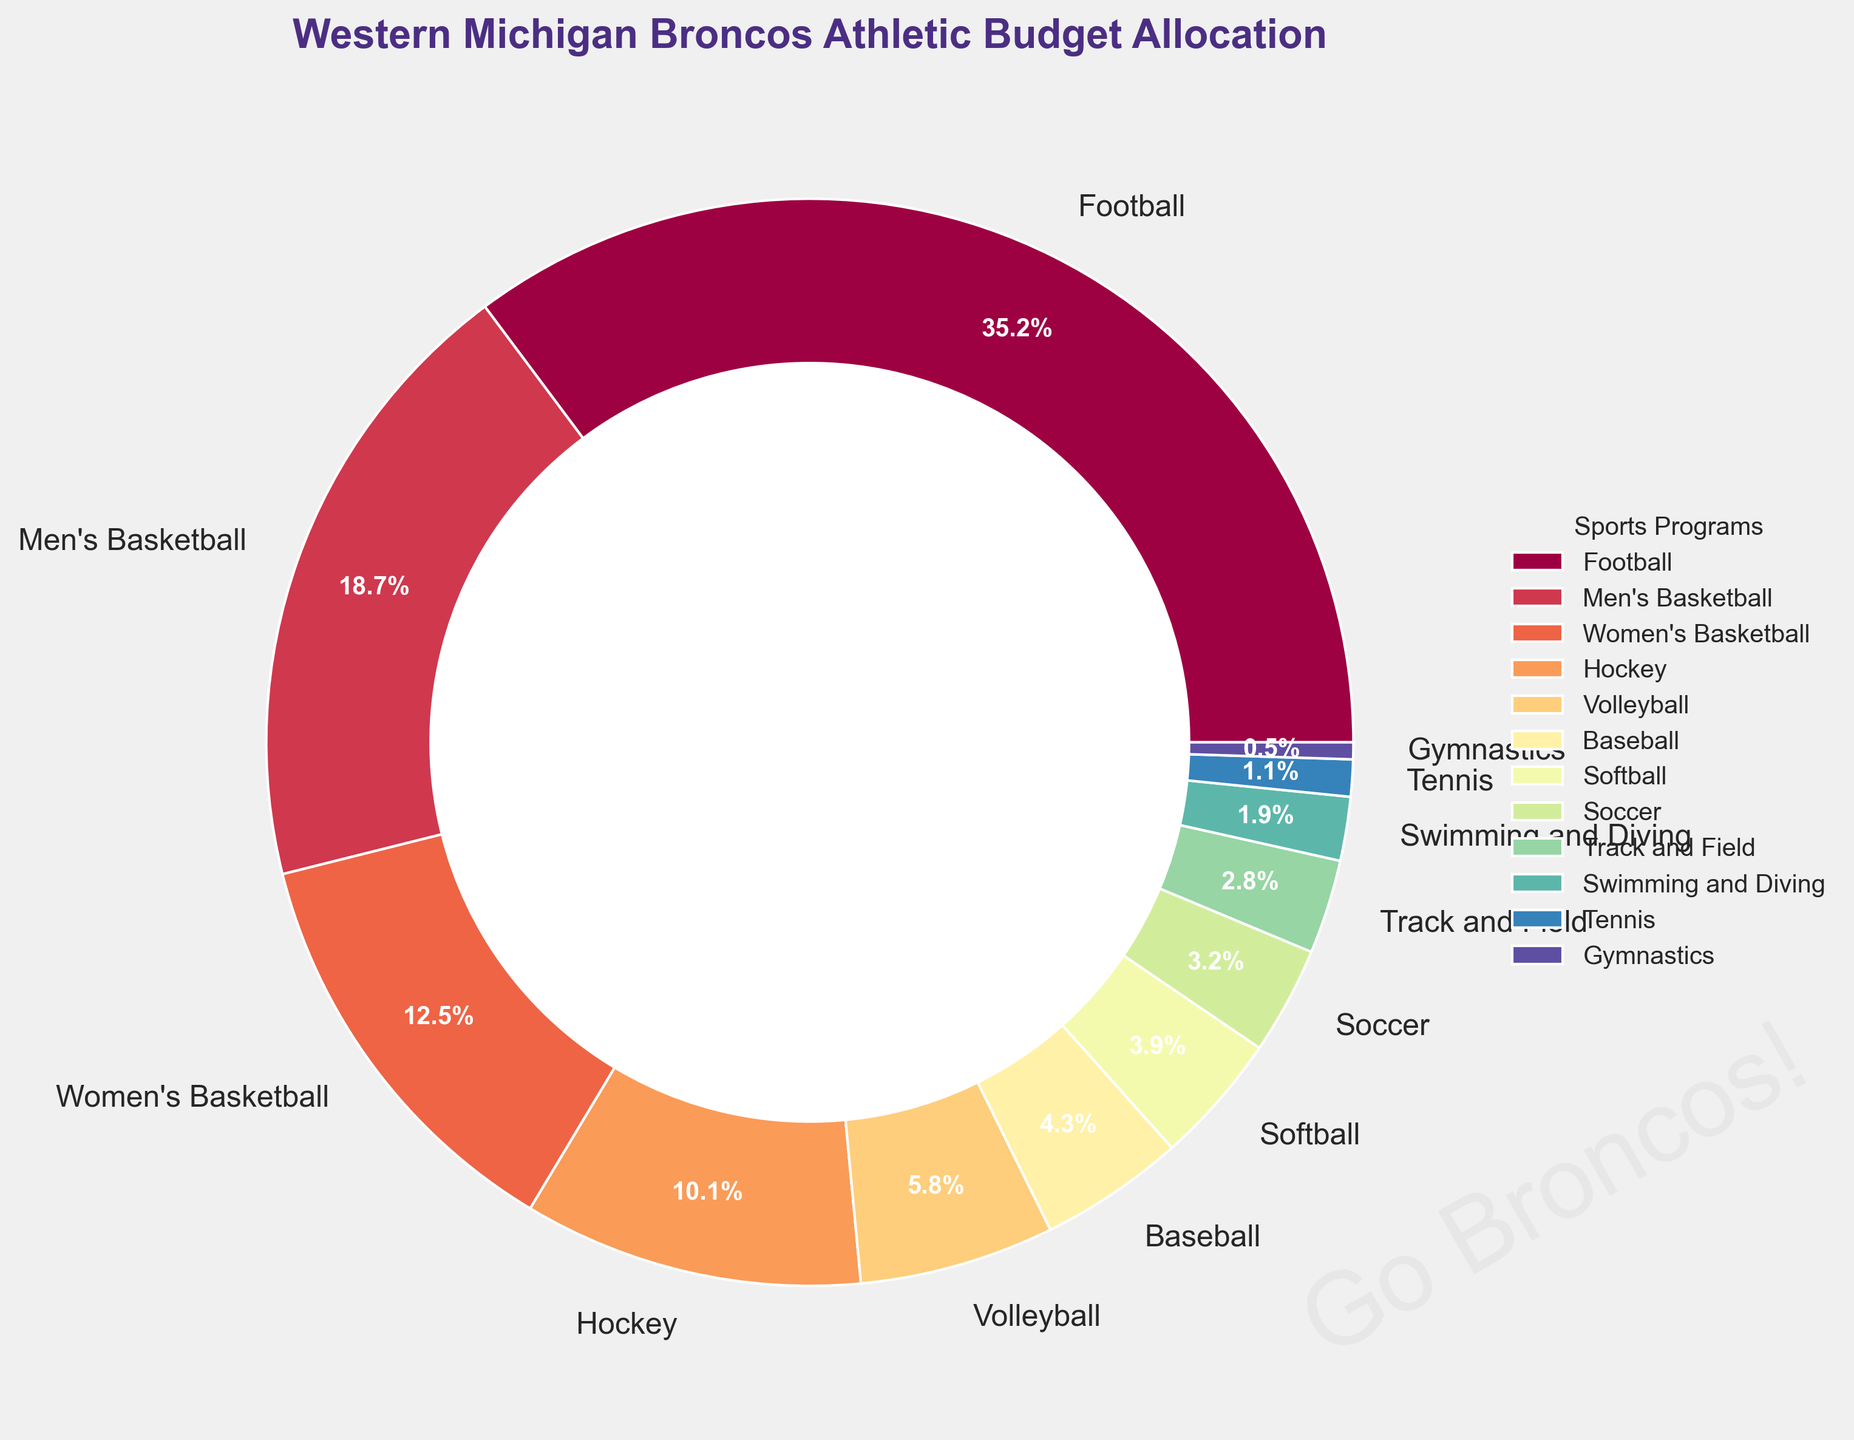What percentage of the athletic budget goes to Men's Basketball? By examining the chart, we see that the Men's Basketball slice is labeled 18.7%.
Answer: 18.7% How much more budget allocation does Football receive compared to Hockey? Football is allocated 35.2% while Hockey gets 10.1%. The difference is 35.2% - 10.1% = 25.1%.
Answer: 25.1% Which sport receives the least budget allocation? The smallest slice is Gymnastics, labeled with 0.5%.
Answer: Gymnastics What is the total budget allocation percentage for all women's sports combined in the plot? First, sum the percentages for Women's Basketball (12.5%), Volleyball (5.8%), Softball (3.9%), Soccer (3.2%), Track and Field (2.8%), Swimming and Diving (1.9%), Tennis (1.1%), and Gymnastics (0.5%). This totals 31.7%.
Answer: 31.7% What is the combined budget allocation for Baseball and Softball? Baseball is allocated 4.3% and Softball 3.9%. Adding them together, we get 4.3% + 3.9% = 8.2%.
Answer: 8.2% Do Men's and Women's Basketball together receive more budget allocation than Football? Men's Basketball gets 18.7% and Women's Basketball 12.5%, together summing up to 31.2%. Football gets 35.2%. Since 31.2% < 35.2%, the combined allocation for Men's and Women's Basketball is less than Football.
Answer: No Which sport has a larger budget allocation, Volleyball or Soccer? Volleyball is allocated 5.8%, and Soccer 3.2%, so Volleyball has a larger budget allocation.
Answer: Volleyball What is the budget allocation for sports other than Football? Excluding Football (35.2%), sum the remaining percentages: 18.7% + 12.5% + 10.1% + 5.8% + 4.3% + 3.9% + 3.2% + 2.8% + 1.9% + 1.1% + 0.5% = 64.8%.
Answer: 64.8% Which sport is represented by the fourth-largest slice? From largest to smallest slices, the fourth-largest is Hockey with a 10.1% allocation.
Answer: Hockey How does the budget share for Swimming and Diving compare to Tennis? Swimming and Diving is allocated 1.9%, while Tennis has 1.1%. Swimming and Diving has a higher allocation.
Answer: Swimming and Diving 